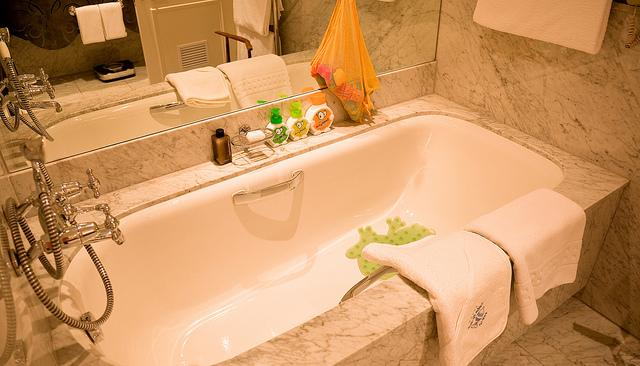Who likely uses this bathtub? children 